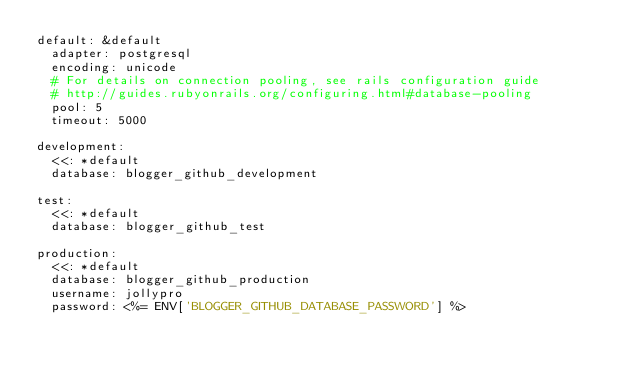Convert code to text. <code><loc_0><loc_0><loc_500><loc_500><_YAML_>default: &default
  adapter: postgresql
  encoding: unicode
  # For details on connection pooling, see rails configuration guide
  # http://guides.rubyonrails.org/configuring.html#database-pooling
  pool: 5
  timeout: 5000

development:
  <<: *default
  database: blogger_github_development

test:
  <<: *default
  database: blogger_github_test

production:
  <<: *default
  database: blogger_github_production
  username: jollypro
  password: <%= ENV['BLOGGER_GITHUB_DATABASE_PASSWORD'] %>
</code> 